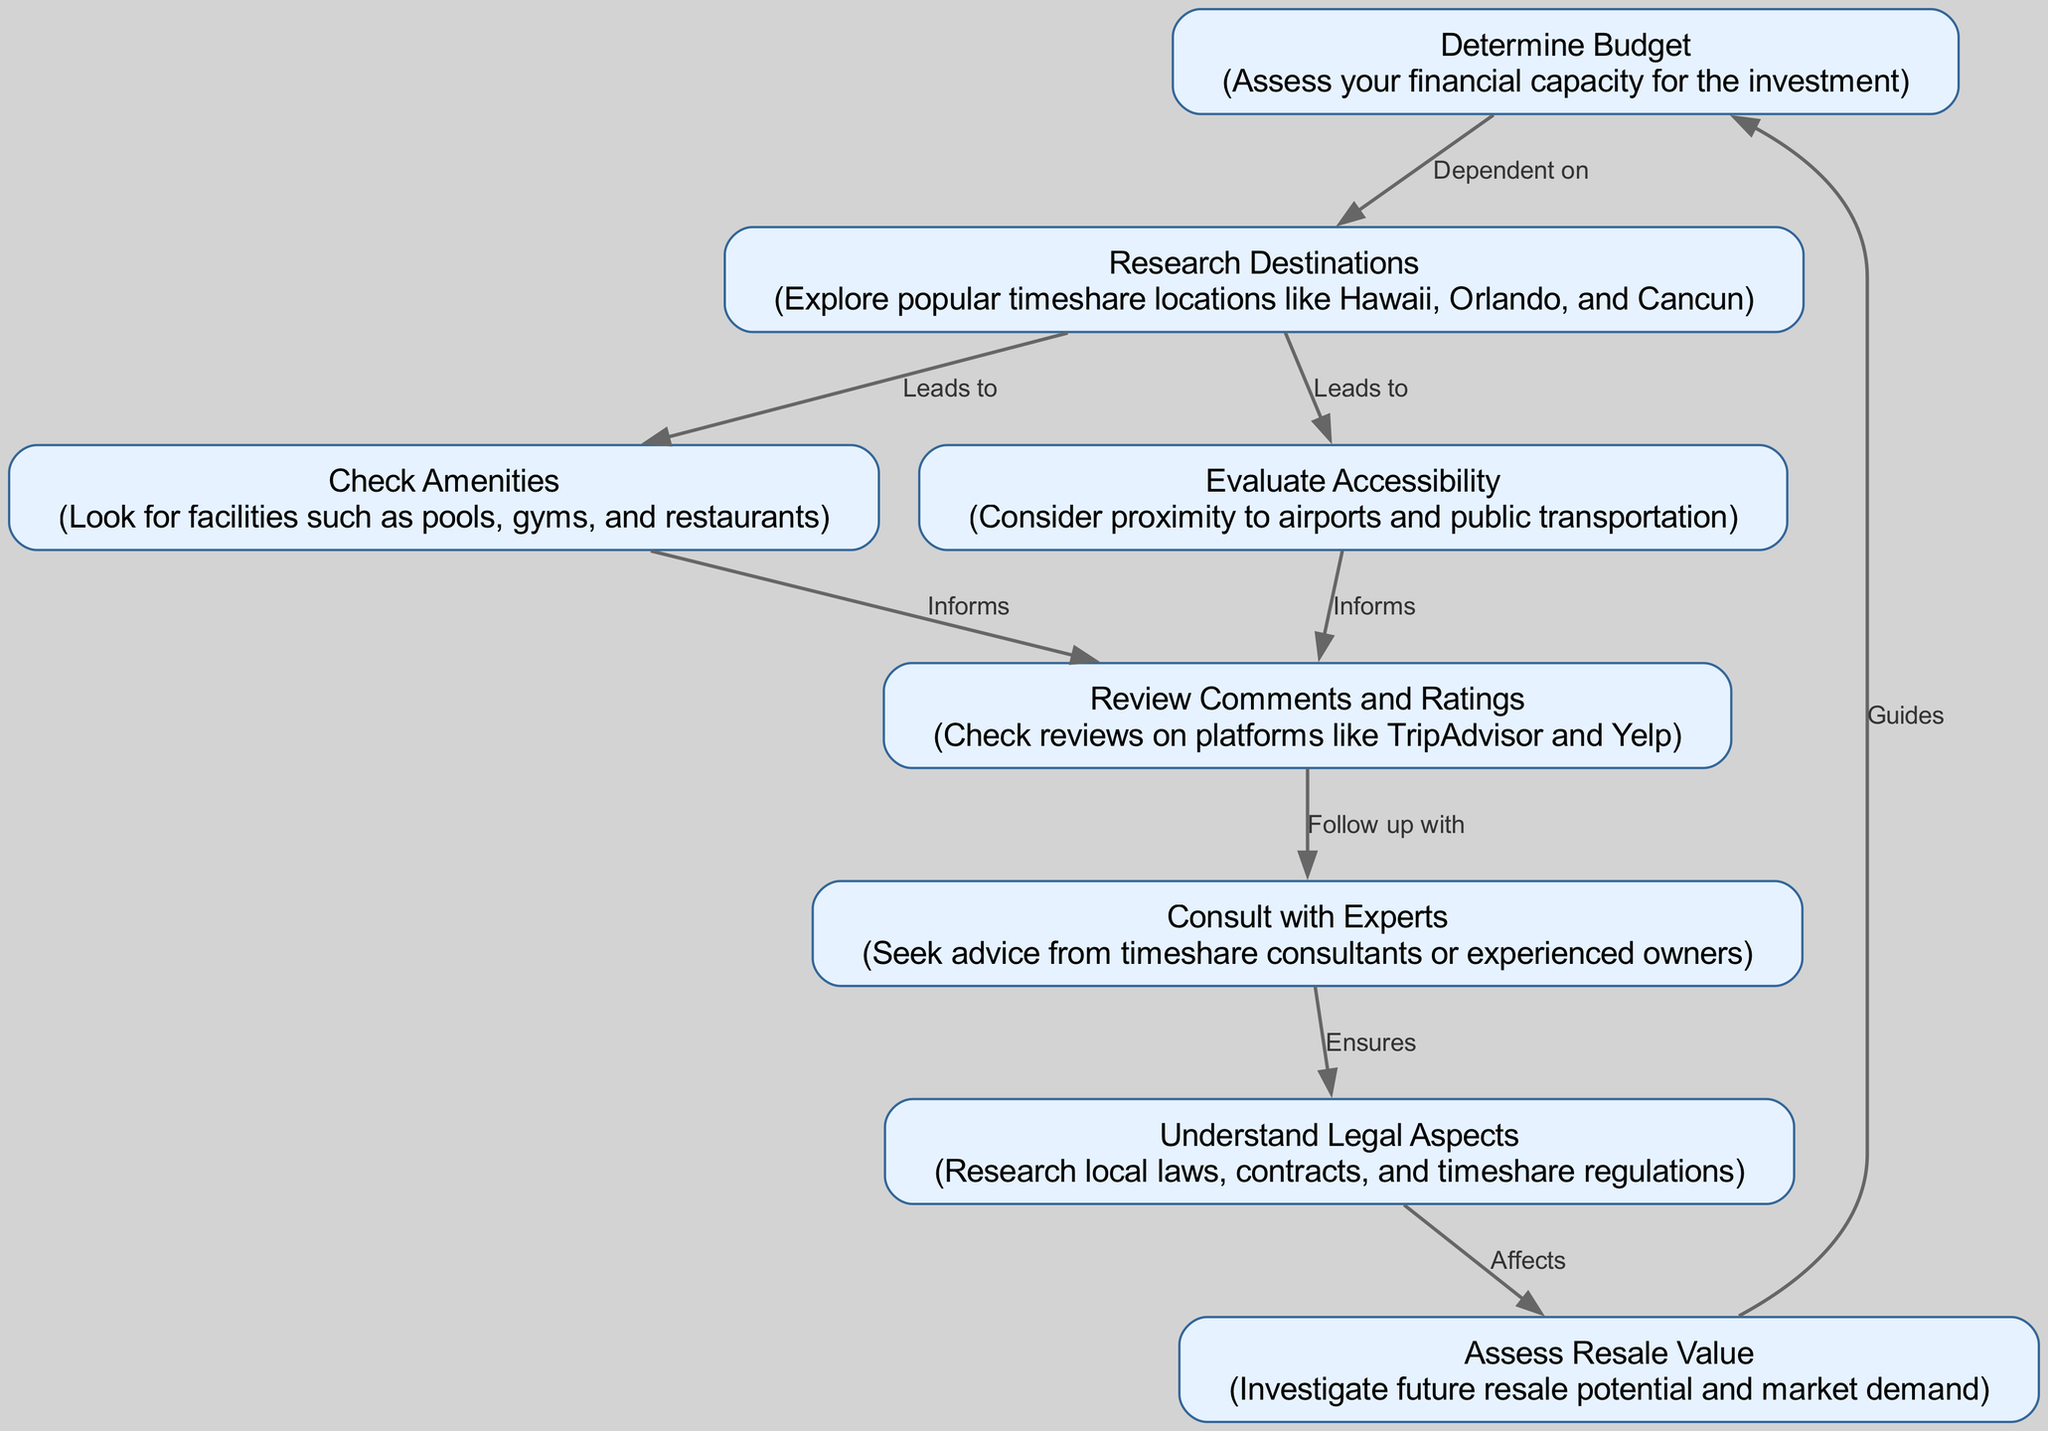What is the first step in the decision-making process? The diagram indicates that the first step is to "Determine Budget,” where individuals assess their financial capacity for the investment.
Answer: Determine Budget How many nodes are present in the diagram? By counting the individual items listed in the nodes section, we identify eight distinct nodes that represent various steps in the decision-making process.
Answer: 8 What does “Research Destinations” lead to? The diagram shows that “Research Destinations” leads to both “Check Amenities” and “Evaluate Accessibility,” indicating these are subsequent considerations after destination research.
Answer: Check Amenities, Evaluate Accessibility What affects the understanding of legal aspects? According to the diagram, the understanding of legal aspects is influenced by consulting with experts, as indicated by the arrow connecting “Consult with Experts” to “Understand Legal Aspects.”
Answer: Consult with Experts How does "Assess Resale Value" relate to "Determine Budget"? The relationship shown in the diagram indicates that “Assess Resale Value” guides back to “Determine Budget,” suggesting that the potential resale value can impact the initial budgeting decision.
Answer: Guides What informs the need to check comments and ratings? The diagram indicates that both “Check Amenities” and “Evaluate Accessibility” inform the decision to check reviews on platforms like TripAdvisor and Yelp, showing a direct dependency relationship.
Answer: Check Amenities, Evaluate Accessibility Which two nodes are dependent on the “Research Destinations” node? The diagram illustrates that “Check Amenities” and “Evaluate Accessibility” are directly dependent on “Research Destinations,” highlighting the importance of destination research in these aspects.
Answer: Check Amenities, Evaluate Accessibility What are the three types of amenities that might be checked? While the diagram does not specify, checking amenities generally includes facilities such as pools, gyms, and restaurants, as stated in the “Check Amenities” node.
Answer: Pools, Gyms, Restaurants What guides the assessment of resale value? The diagram points to “Understand Legal Aspects” as a critical factor that affects the assessment of resale value, indicating its importance in making informed decisions regarding the timeshare.
Answer: Understand Legal Aspects 